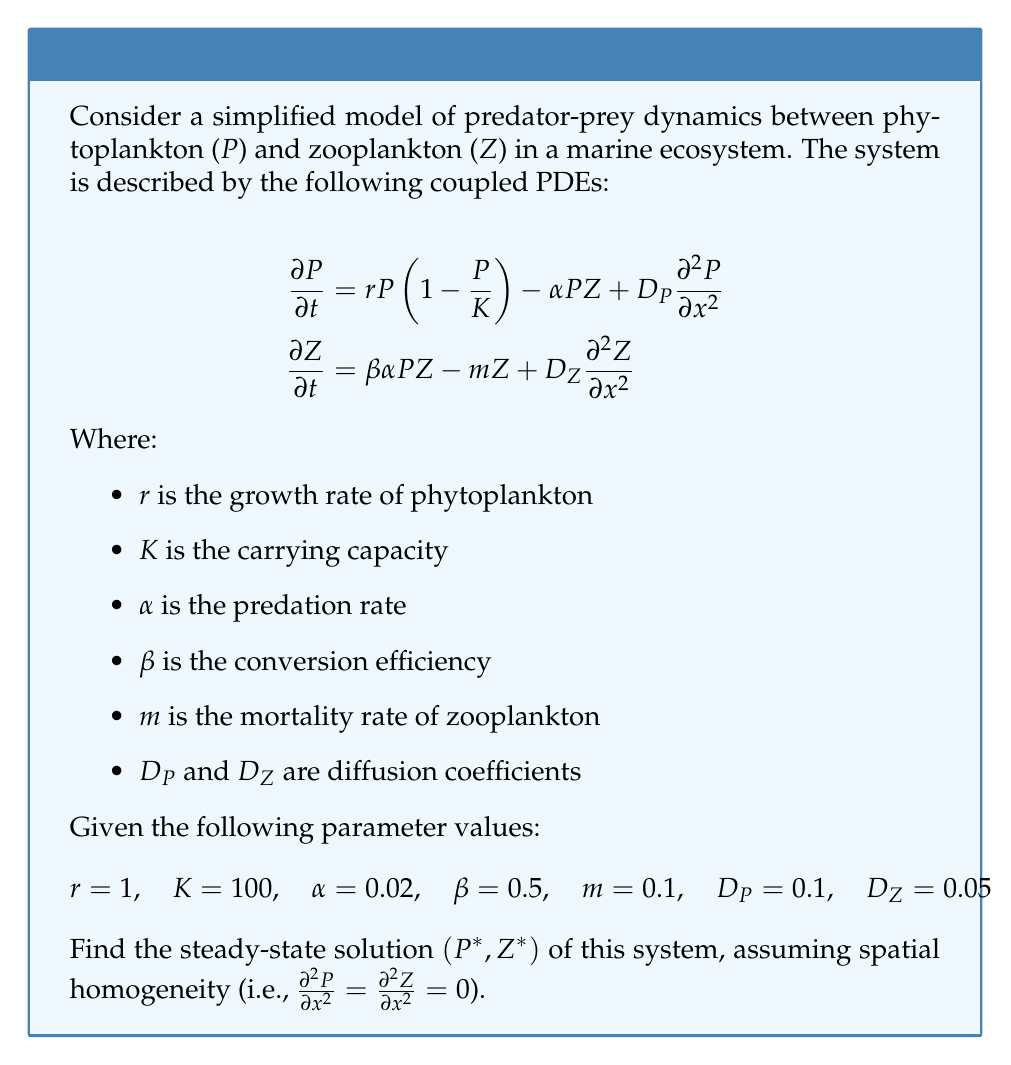Could you help me with this problem? To find the steady-state solution, we set the time derivatives to zero and assume spatial homogeneity:

$$\begin{align}
0 &= r P \left(1 - \frac{P}{K}\right) - \alpha PZ \\
0 &= \beta \alpha PZ - m Z
\end{align}$$

Step 1: From the second equation, we can find a relationship between $P$ and $Z$:
$$\beta \alpha P = m$$
$$P^* = \frac{m}{\beta \alpha}$$

Step 2: Substitute this into the first equation:
$$0 = r P^* \left(1 - \frac{P^*}{K}\right) - \alpha P^* Z^*$$

Step 3: Solve for $Z^*$:
$$Z^* = \frac{r}{\alpha} \left(1 - \frac{P^*}{K}\right)$$

Step 4: Calculate $P^*$ using the given parameter values:
$$P^* = \frac{0.1}{0.5 \cdot 0.02} = 10$$

Step 5: Calculate $Z^*$:
$$Z^* = \frac{1}{0.02} \left(1 - \frac{10}{100}\right) = 45$$

Therefore, the steady-state solution is $(P^*, Z^*) = (10, 45)$.
Answer: $(P^*, Z^*) = (10, 45)$ 